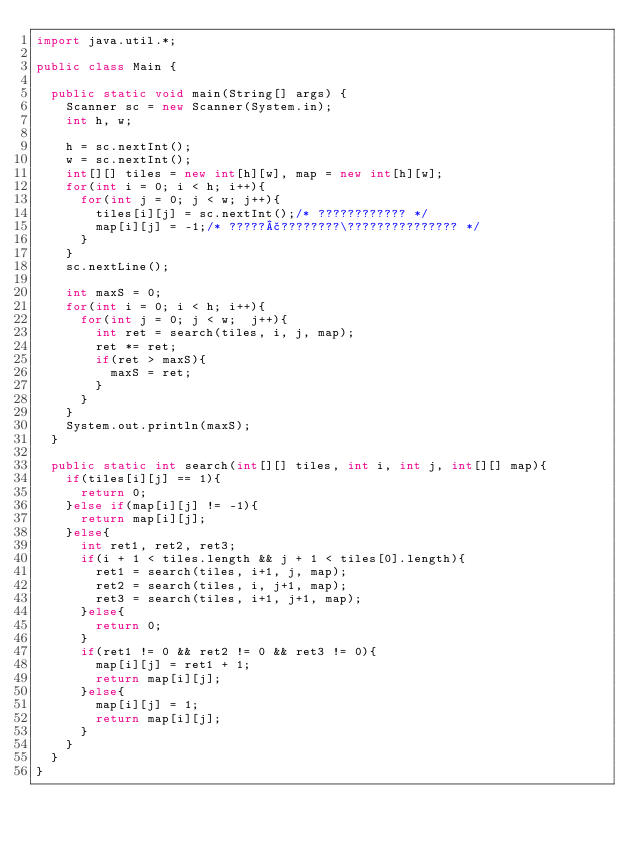Convert code to text. <code><loc_0><loc_0><loc_500><loc_500><_Java_>import java.util.*;

public class Main {

	public static void main(String[] args) {
		Scanner sc = new Scanner(System.in);
		int h, w;
		
		h = sc.nextInt();
		w = sc.nextInt();
		int[][] tiles = new int[h][w], map = new int[h][w];
		for(int i = 0; i < h; i++){
			for(int j = 0; j < w; j++){
				tiles[i][j] = sc.nextInt();/* ???????????? */
				map[i][j] = -1;/* ?????£????????\??????????????? */
			}
		}
		sc.nextLine();

		int maxS = 0;
		for(int i = 0; i < h; i++){
			for(int j = 0; j < w;  j++){
				int ret = search(tiles, i, j, map);
				ret *= ret;
				if(ret > maxS){
					maxS = ret;
				}
			}
		}
		System.out.println(maxS);		
	}
	
	public static int search(int[][] tiles, int i, int j, int[][] map){
		if(tiles[i][j] == 1){
			return 0;
		}else if(map[i][j] != -1){
			return map[i][j];
		}else{
			int ret1, ret2, ret3;
			if(i + 1 < tiles.length && j + 1 < tiles[0].length){
				ret1 = search(tiles, i+1, j, map);
				ret2 = search(tiles, i, j+1, map);
				ret3 = search(tiles, i+1, j+1, map);
			}else{
				return 0;
			}
			if(ret1 != 0 && ret2 != 0 && ret3 != 0){
				map[i][j] = ret1 + 1;
				return map[i][j];
			}else{
				map[i][j] = 1;
				return map[i][j];
			}
		}
	}
}</code> 